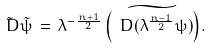<formula> <loc_0><loc_0><loc_500><loc_500>\tilde { \ D } \tilde { \psi } \, = \, \lambda ^ { - \frac { n + 1 } { 2 } } \, \widetilde { \left ( \ D ( \lambda ^ { \frac { n - 1 } { 2 } } \psi ) \right ) } .</formula> 